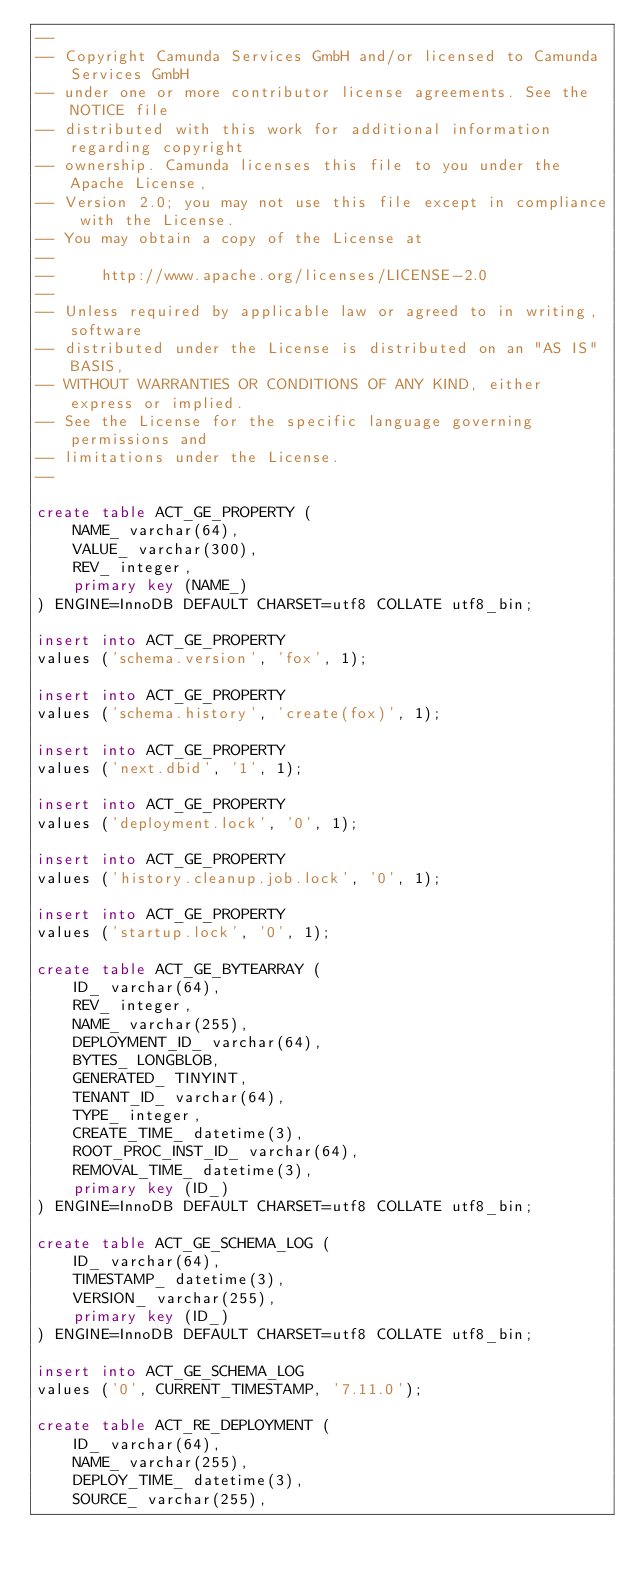<code> <loc_0><loc_0><loc_500><loc_500><_SQL_>--
-- Copyright Camunda Services GmbH and/or licensed to Camunda Services GmbH
-- under one or more contributor license agreements. See the NOTICE file
-- distributed with this work for additional information regarding copyright
-- ownership. Camunda licenses this file to you under the Apache License,
-- Version 2.0; you may not use this file except in compliance with the License.
-- You may obtain a copy of the License at
--
--     http://www.apache.org/licenses/LICENSE-2.0
--
-- Unless required by applicable law or agreed to in writing, software
-- distributed under the License is distributed on an "AS IS" BASIS,
-- WITHOUT WARRANTIES OR CONDITIONS OF ANY KIND, either express or implied.
-- See the License for the specific language governing permissions and
-- limitations under the License.
--

create table ACT_GE_PROPERTY (
    NAME_ varchar(64),
    VALUE_ varchar(300),
    REV_ integer,
    primary key (NAME_)
) ENGINE=InnoDB DEFAULT CHARSET=utf8 COLLATE utf8_bin;

insert into ACT_GE_PROPERTY
values ('schema.version', 'fox', 1);

insert into ACT_GE_PROPERTY
values ('schema.history', 'create(fox)', 1);

insert into ACT_GE_PROPERTY
values ('next.dbid', '1', 1);

insert into ACT_GE_PROPERTY
values ('deployment.lock', '0', 1);

insert into ACT_GE_PROPERTY
values ('history.cleanup.job.lock', '0', 1);

insert into ACT_GE_PROPERTY
values ('startup.lock', '0', 1);

create table ACT_GE_BYTEARRAY (
    ID_ varchar(64),
    REV_ integer,
    NAME_ varchar(255),
    DEPLOYMENT_ID_ varchar(64),
    BYTES_ LONGBLOB,
    GENERATED_ TINYINT,
    TENANT_ID_ varchar(64),
    TYPE_ integer,
    CREATE_TIME_ datetime(3),
    ROOT_PROC_INST_ID_ varchar(64),
    REMOVAL_TIME_ datetime(3),
    primary key (ID_)
) ENGINE=InnoDB DEFAULT CHARSET=utf8 COLLATE utf8_bin;

create table ACT_GE_SCHEMA_LOG (
    ID_ varchar(64),
    TIMESTAMP_ datetime(3),
    VERSION_ varchar(255),
    primary key (ID_)
) ENGINE=InnoDB DEFAULT CHARSET=utf8 COLLATE utf8_bin;

insert into ACT_GE_SCHEMA_LOG
values ('0', CURRENT_TIMESTAMP, '7.11.0');

create table ACT_RE_DEPLOYMENT (
    ID_ varchar(64),
    NAME_ varchar(255),
    DEPLOY_TIME_ datetime(3),
    SOURCE_ varchar(255),</code> 